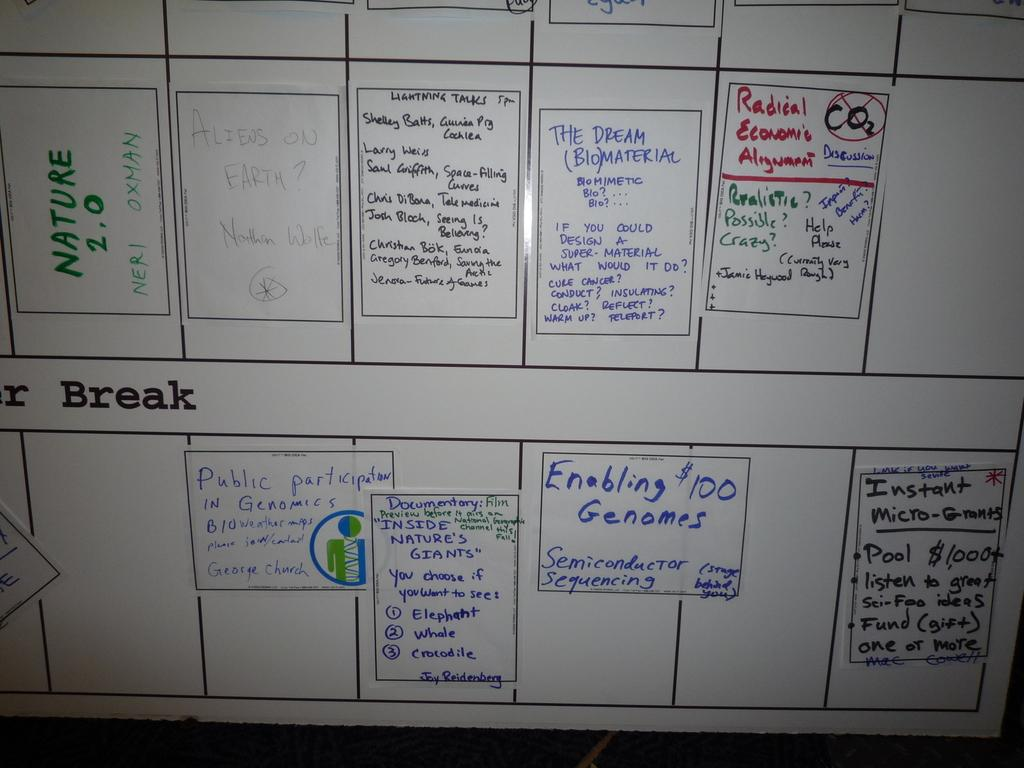<image>
Present a compact description of the photo's key features. A whiteboard with Nature 2.0 written on it in green marker. 